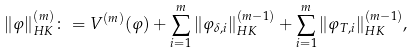Convert formula to latex. <formula><loc_0><loc_0><loc_500><loc_500>\| \varphi \| _ { H K } ^ { ( m ) } \colon = V ^ { ( m ) } ( \varphi ) + \sum _ { i = 1 } ^ { m } \| \varphi _ { \delta , i } \| _ { H K } ^ { ( m - 1 ) } + \sum _ { i = 1 } ^ { m } \| \varphi _ { T , i } \| _ { H K } ^ { ( m - 1 ) } ,</formula> 